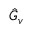<formula> <loc_0><loc_0><loc_500><loc_500>\hat { G } _ { v }</formula> 